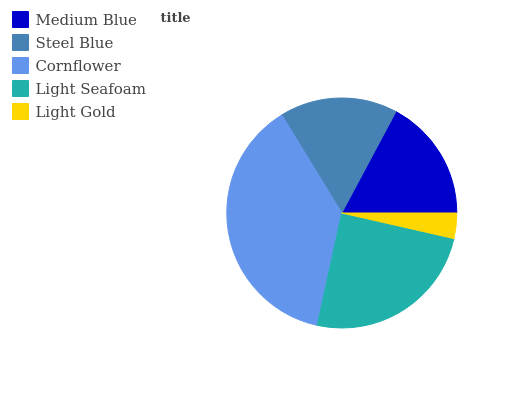Is Light Gold the minimum?
Answer yes or no. Yes. Is Cornflower the maximum?
Answer yes or no. Yes. Is Steel Blue the minimum?
Answer yes or no. No. Is Steel Blue the maximum?
Answer yes or no. No. Is Medium Blue greater than Steel Blue?
Answer yes or no. Yes. Is Steel Blue less than Medium Blue?
Answer yes or no. Yes. Is Steel Blue greater than Medium Blue?
Answer yes or no. No. Is Medium Blue less than Steel Blue?
Answer yes or no. No. Is Medium Blue the high median?
Answer yes or no. Yes. Is Medium Blue the low median?
Answer yes or no. Yes. Is Light Seafoam the high median?
Answer yes or no. No. Is Light Seafoam the low median?
Answer yes or no. No. 